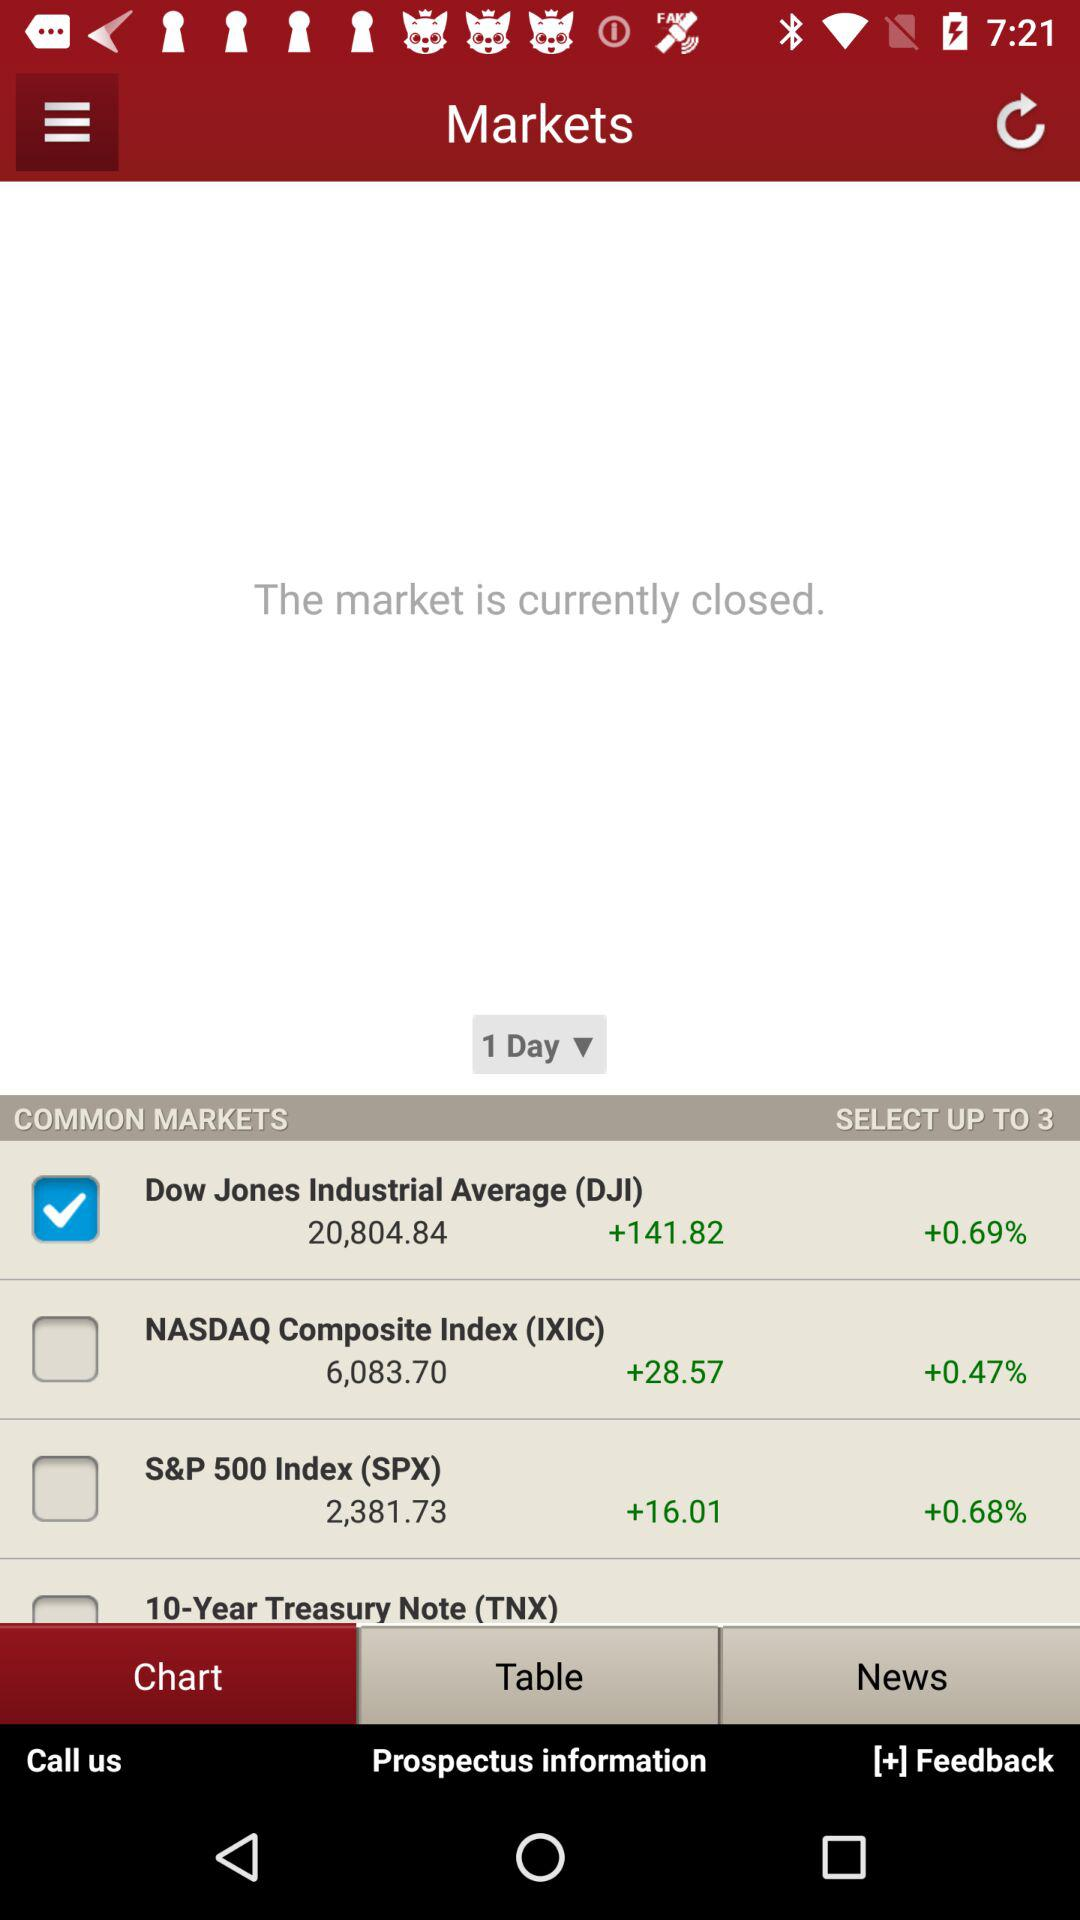What is the stock price of "Dow Jones Industrial Average"? The stock price of "Dow Jones Industrial Average" is 20,804.84. 